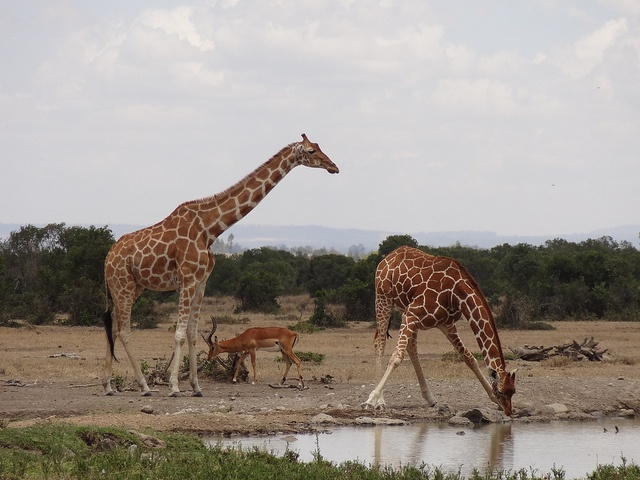Describe the objects in this image and their specific colors. I can see giraffe in lightgray, maroon, brown, and gray tones and giraffe in lightgray, maroon, black, and gray tones in this image. 